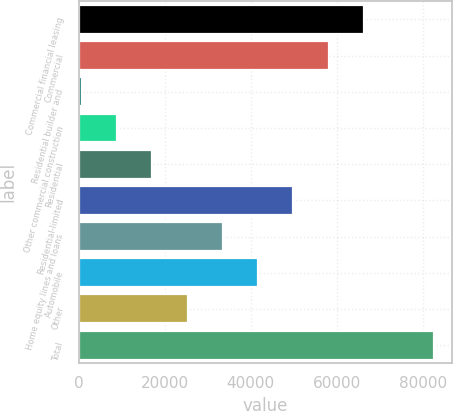<chart> <loc_0><loc_0><loc_500><loc_500><bar_chart><fcel>Commercial financial leasing<fcel>Commercial<fcel>Residential builder and<fcel>Other commercial construction<fcel>Residential<fcel>Residential-limited<fcel>Home equity lines and loans<fcel>Automobile<fcel>Other<fcel>Total<nl><fcel>66275.4<fcel>58091.6<fcel>805<fcel>8988.8<fcel>17172.6<fcel>49907.8<fcel>33540.2<fcel>41724<fcel>25356.4<fcel>82643<nl></chart> 